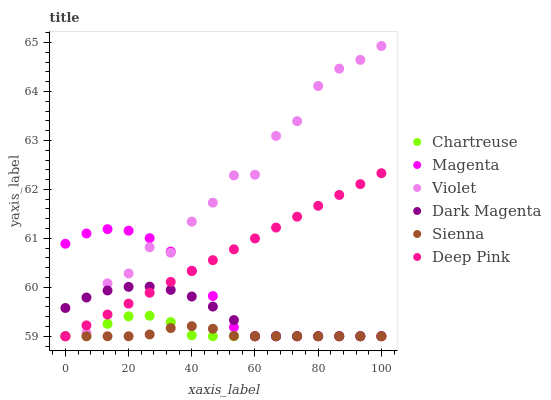Does Sienna have the minimum area under the curve?
Answer yes or no. Yes. Does Violet have the maximum area under the curve?
Answer yes or no. Yes. Does Dark Magenta have the minimum area under the curve?
Answer yes or no. No. Does Dark Magenta have the maximum area under the curve?
Answer yes or no. No. Is Deep Pink the smoothest?
Answer yes or no. Yes. Is Violet the roughest?
Answer yes or no. Yes. Is Dark Magenta the smoothest?
Answer yes or no. No. Is Dark Magenta the roughest?
Answer yes or no. No. Does Deep Pink have the lowest value?
Answer yes or no. Yes. Does Violet have the highest value?
Answer yes or no. Yes. Does Dark Magenta have the highest value?
Answer yes or no. No. Does Chartreuse intersect Violet?
Answer yes or no. Yes. Is Chartreuse less than Violet?
Answer yes or no. No. Is Chartreuse greater than Violet?
Answer yes or no. No. 